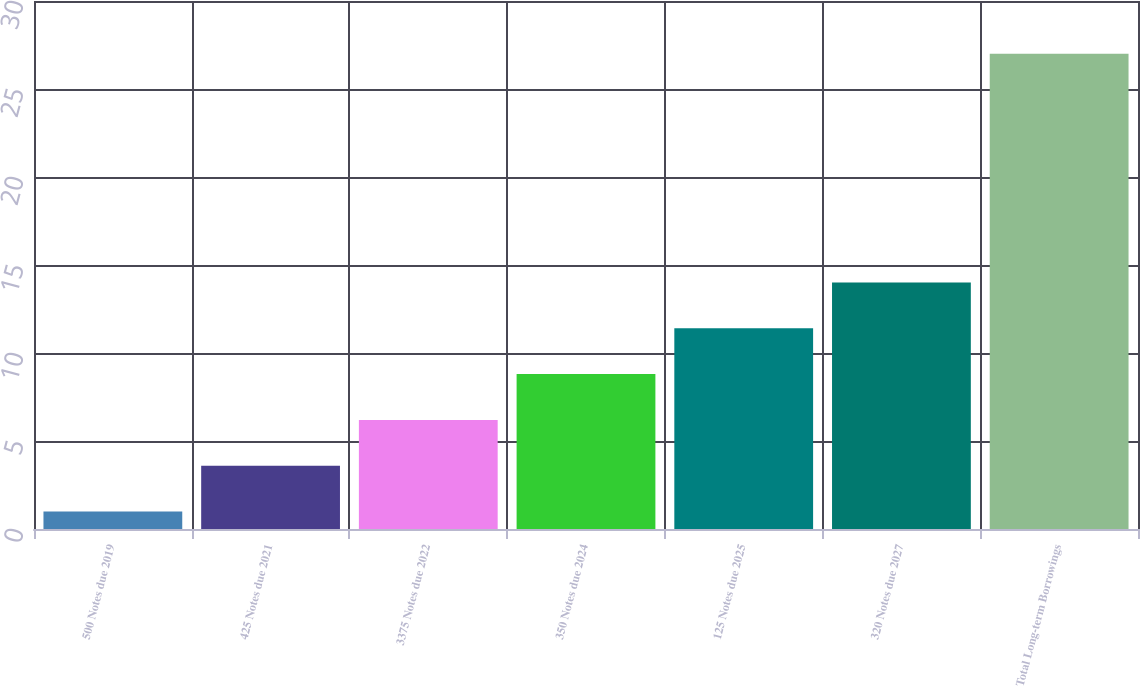<chart> <loc_0><loc_0><loc_500><loc_500><bar_chart><fcel>500 Notes due 2019<fcel>425 Notes due 2021<fcel>3375 Notes due 2022<fcel>350 Notes due 2024<fcel>125 Notes due 2025<fcel>320 Notes due 2027<fcel>Total Long-term Borrowings<nl><fcel>1<fcel>3.6<fcel>6.2<fcel>8.8<fcel>11.4<fcel>14<fcel>27<nl></chart> 